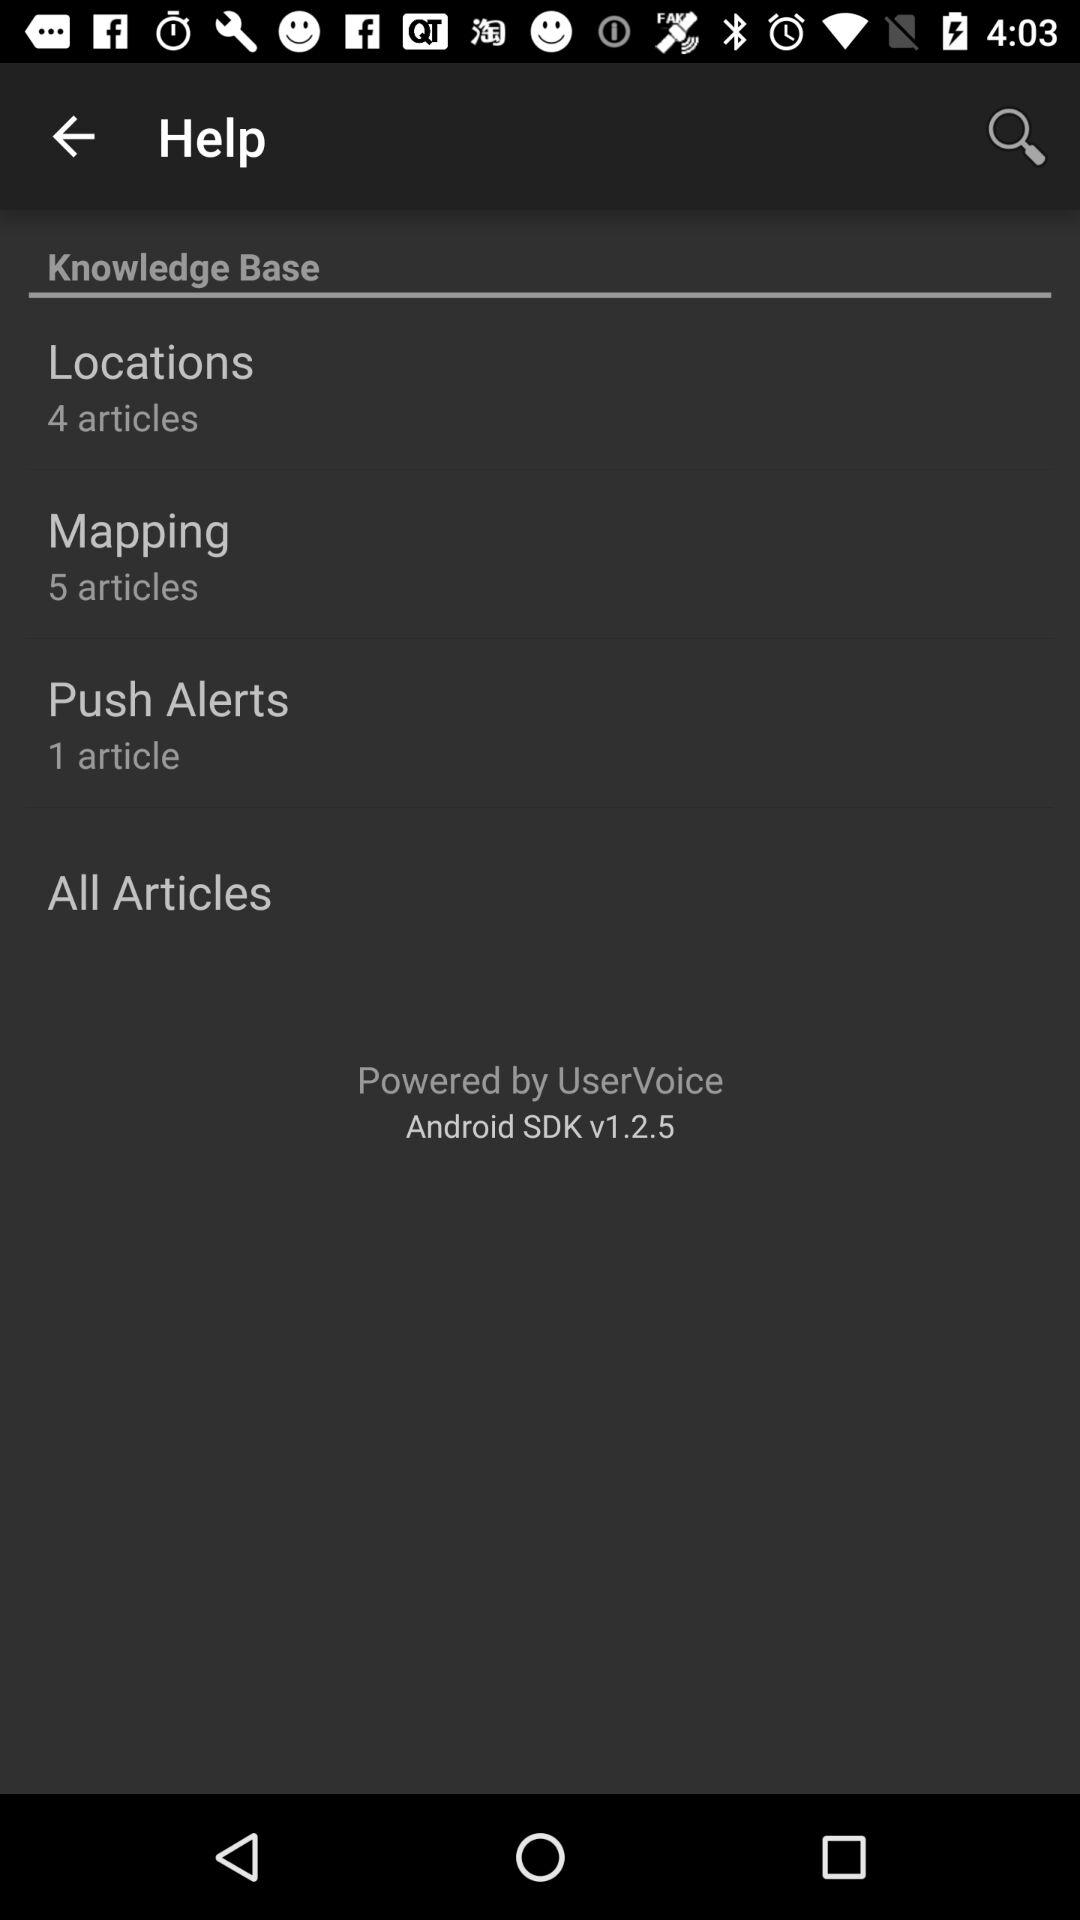How many articles are there in locations? There are 4 articles. 